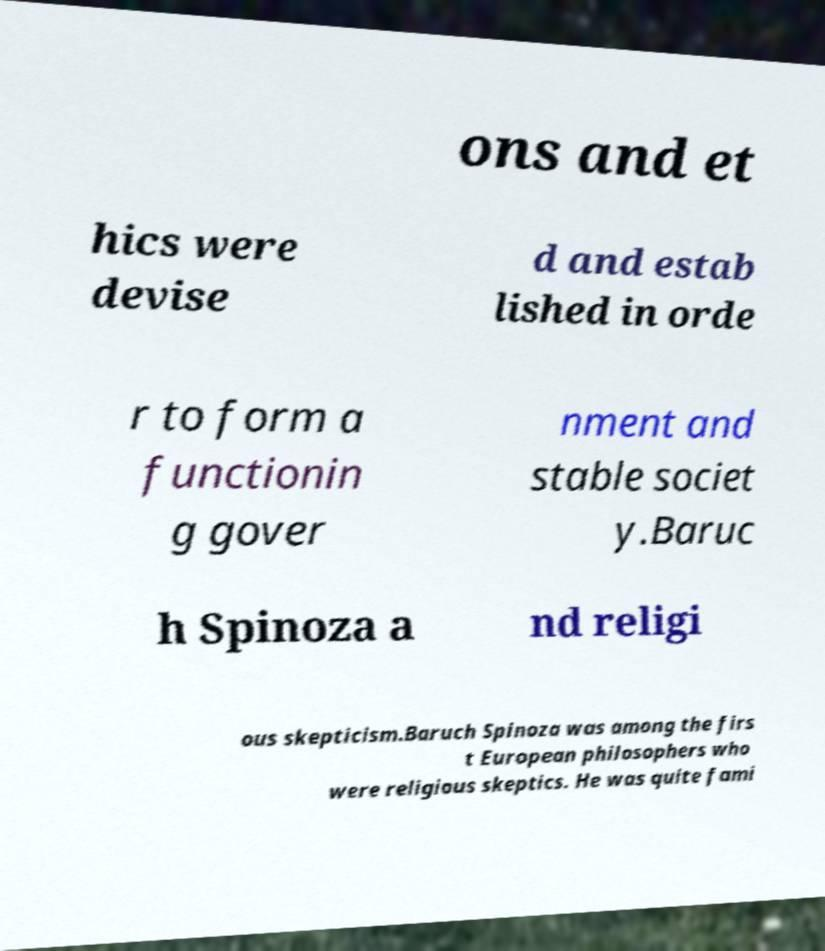Please identify and transcribe the text found in this image. ons and et hics were devise d and estab lished in orde r to form a functionin g gover nment and stable societ y.Baruc h Spinoza a nd religi ous skepticism.Baruch Spinoza was among the firs t European philosophers who were religious skeptics. He was quite fami 